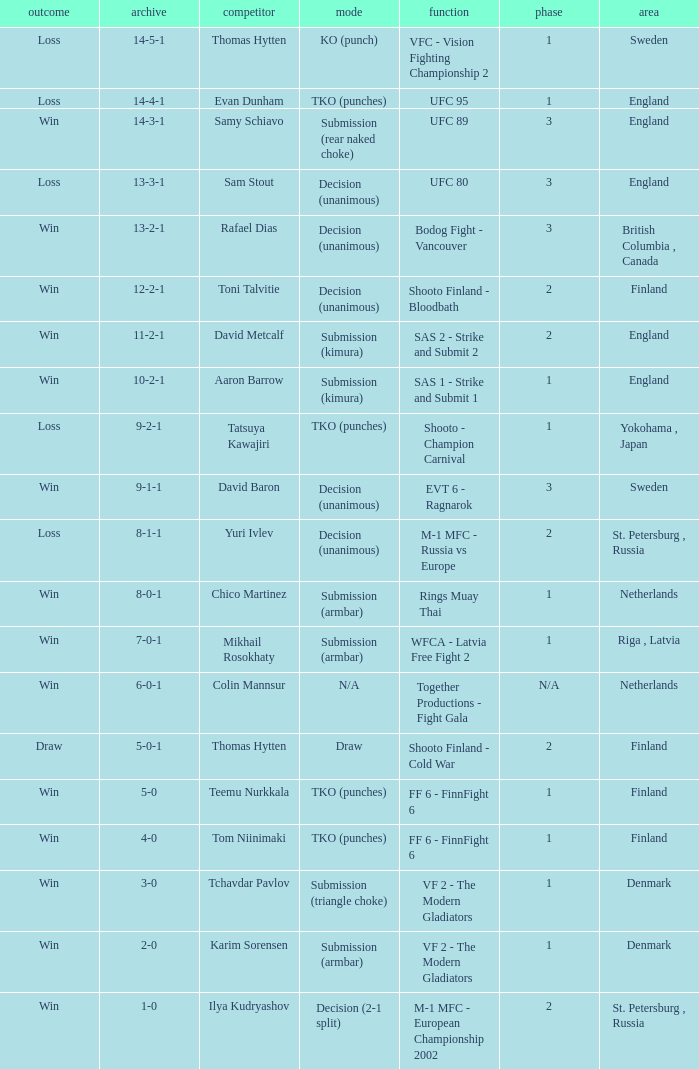Who was the opponent with a record of 14-4-1 and has a round of 1? Evan Dunham. 